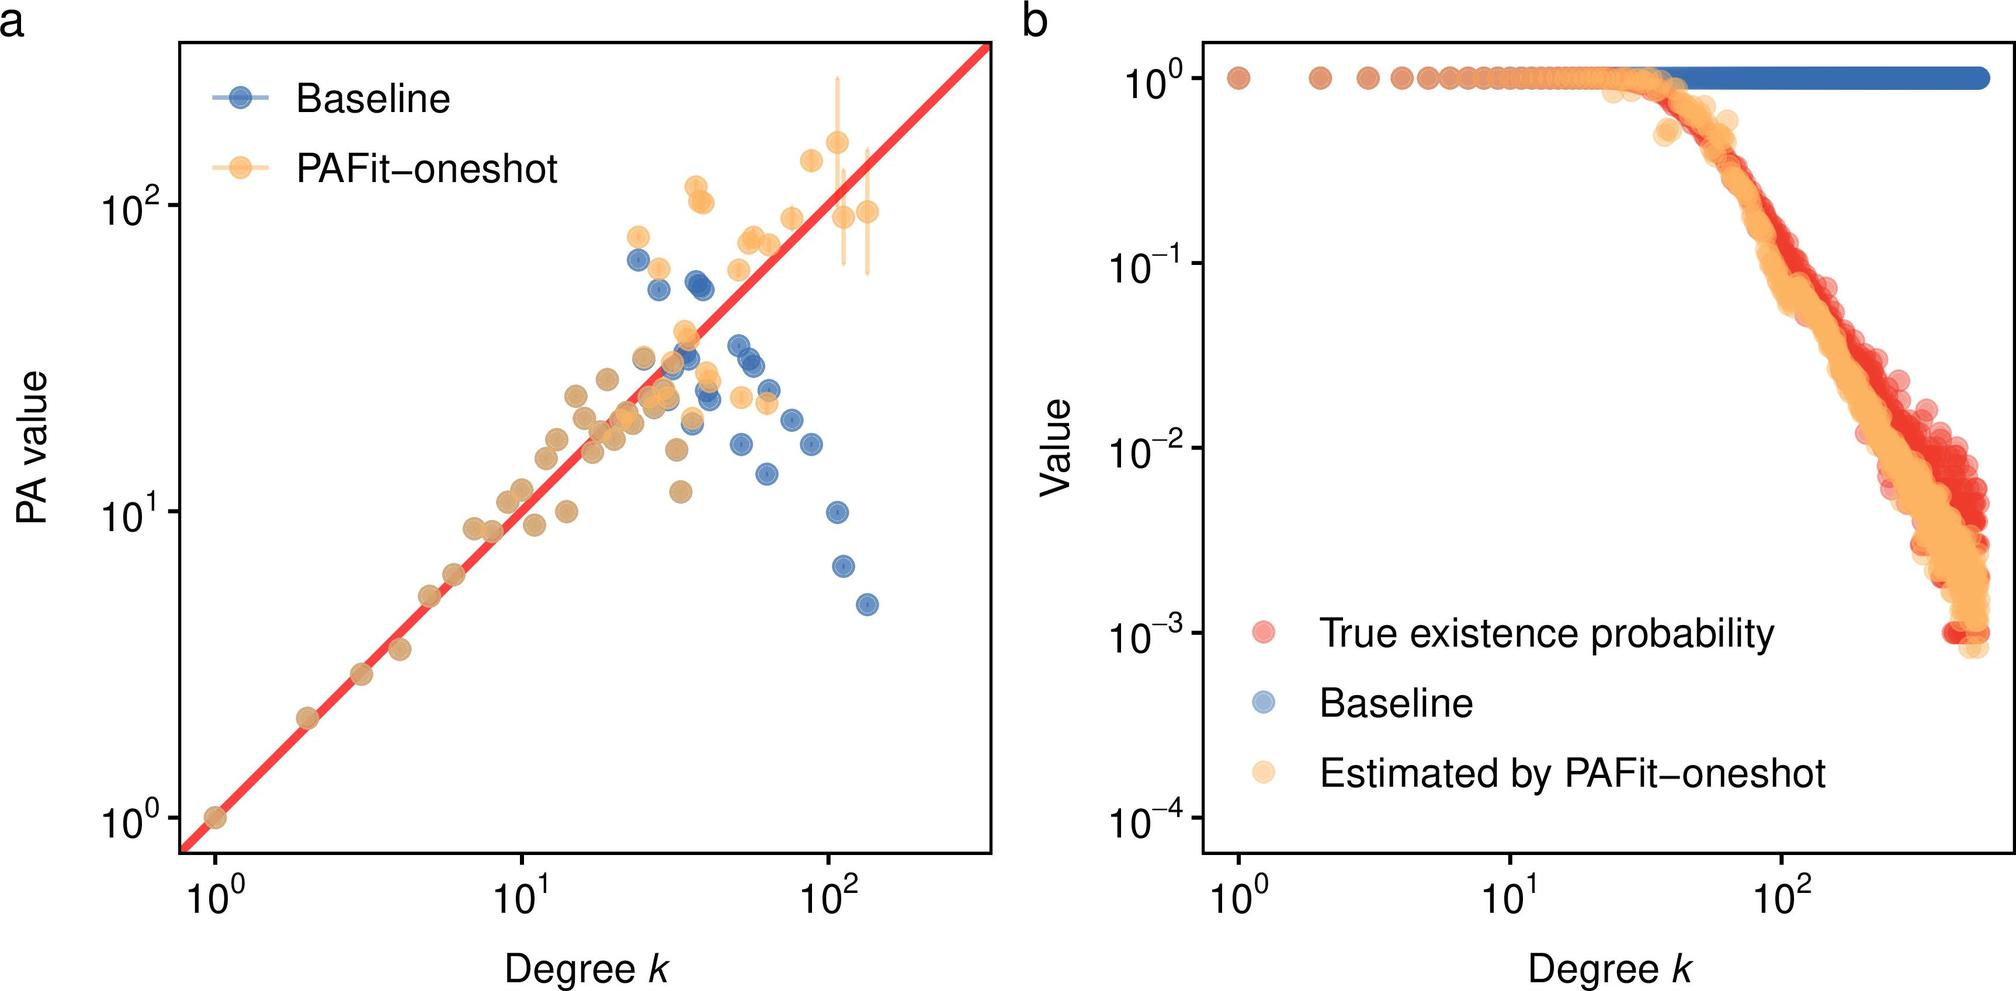Based on figure b, what does the color gradient represent in the context of true existence probability and estimates by PAFit-oneshot? The color gradient represents the error margin between the estimated and true values. The color gradient indicates the density of data points at each degree k. The color gradient shows the confidence interval for the PAFit-oneshot estimates. The color gradient distinguishes between the baseline and the PAFit-oneshot estimates. - The color gradient in figure b changes from blue to red, aligning with the density of data points, where darker colors represent a higher concentration of points. This suggests that the gradient is indicative of the point density rather than an error margin or confidence interval. Therefore, the correct answer is B. 